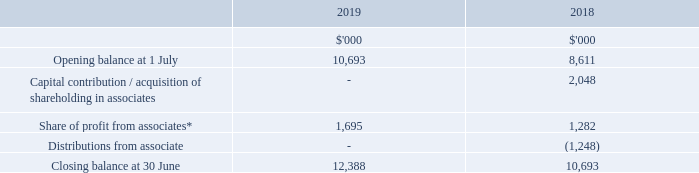Interest in associates
*Included within share of profit from associates is $1,917,000 representing NSR’s share of fair value gains related to investment properties held by joint ventures and associates (30 June 2018: $1,383,000).
The Group owns 24.9% (2018: 24.9%) of the Australia Prime Storage Fund (“APSF”). APSF is a partnership with Universal Self Storage to facilitate the development and ownership of multiple premium grade selfstorage centres in select cities around Australia.
During the year ended 30 June 2019, National Storage (Operations) Pty Ltd earned fees of $0.8m from APSF associated with the design, development, financing of the construction process, and ongoing management of centres (see note 17) (30 June 2018: $0.7m).
As at 30 June 2019, APSF had two operating centres in Queensland, Australia, with a third asset under construction in Victoria, Australia.
Following the financial year end, on 26 July 2019, the Group purchased two storage centre investment properties from APSF for $42.6m, and reached an agreement to purchase a third asset for $21.35m on completion of construction (see note 23). During the year ended 30 June 2018, the Group purchased a storage centre investment property asset in Queensland, Australia from APSF for $14m.
As at 30 June 2019, APSF had contractual commitments of $2.8m in place for the construction of one storage centre in Victoria, Australia. Neither associate had any contingent liabilities or any other capital commitments at 30 June 2019 or 30 June 2018. As at 30 June 2019, APSF had contractual commitments of $2.8m in place for the construction of one storage centre in Victoria, Australia. Neither associate had any contingent liabilities or any other capital commitments at 30 June 2019 or 30 June 2018.
The Group holds a 24% (30 June 2018: 24.8%) holding in Spacer Marketplaces Pty Ltd (“Spacer”). Spacer operate online peer-to-peer marketplaces for self-storage and parking.
What was the share of profit from associates representing NSRs in 2019 and 2018? $1,917,000, $1,383,000. What percentage does the Group own of the Australian Prime Storage Fund in 2018? 24.9%. What was the Capital contribution / acquisition of shareholding in associates in 2018?
Answer scale should be: thousand. 2,048. What was the average Capital contribution / acquisition of shareholding in associates for 2018 and 2019?
Answer scale should be: thousand. (0 + 2,048) / 2
Answer: 1024. What is the change in the Share of profit from associates from 2018 to 2019?
Answer scale should be: thousand. 1,695 - 1,282
Answer: 413. In which year was the Closing balance at 30 June less than 11,000 thousands? Locate and analyze closing balance at 30 june in row 7
answer: 2018. 